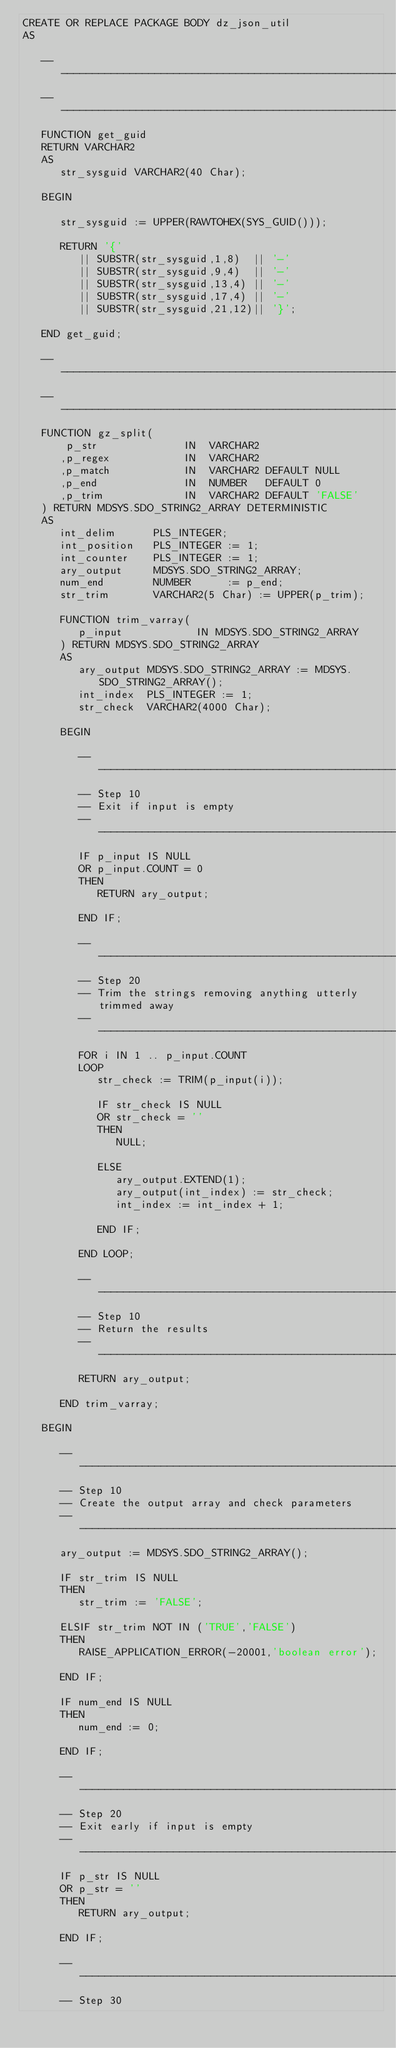<code> <loc_0><loc_0><loc_500><loc_500><_SQL_>CREATE OR REPLACE PACKAGE BODY dz_json_util
AS

   -----------------------------------------------------------------------------
   -----------------------------------------------------------------------------
   FUNCTION get_guid
   RETURN VARCHAR2
   AS
      str_sysguid VARCHAR2(40 Char);
      
   BEGIN
   
      str_sysguid := UPPER(RAWTOHEX(SYS_GUID()));
      
      RETURN '{' 
         || SUBSTR(str_sysguid,1,8)  || '-'
         || SUBSTR(str_sysguid,9,4)  || '-'
         || SUBSTR(str_sysguid,13,4) || '-'
         || SUBSTR(str_sysguid,17,4) || '-'
         || SUBSTR(str_sysguid,21,12)|| '}';
   
   END get_guid;
   
   -----------------------------------------------------------------------------
   -----------------------------------------------------------------------------
   FUNCTION gz_split(
       p_str              IN  VARCHAR2
      ,p_regex            IN  VARCHAR2
      ,p_match            IN  VARCHAR2 DEFAULT NULL
      ,p_end              IN  NUMBER   DEFAULT 0
      ,p_trim             IN  VARCHAR2 DEFAULT 'FALSE'
   ) RETURN MDSYS.SDO_STRING2_ARRAY DETERMINISTIC 
   AS
      int_delim      PLS_INTEGER;
      int_position   PLS_INTEGER := 1;
      int_counter    PLS_INTEGER := 1;
      ary_output     MDSYS.SDO_STRING2_ARRAY;
      num_end        NUMBER      := p_end;
      str_trim       VARCHAR2(5 Char) := UPPER(p_trim);
      
      FUNCTION trim_varray(
         p_input            IN MDSYS.SDO_STRING2_ARRAY
      ) RETURN MDSYS.SDO_STRING2_ARRAY
      AS
         ary_output MDSYS.SDO_STRING2_ARRAY := MDSYS.SDO_STRING2_ARRAY();
         int_index  PLS_INTEGER := 1;
         str_check  VARCHAR2(4000 Char);
         
      BEGIN

         --------------------------------------------------------------------------
         -- Step 10
         -- Exit if input is empty
         --------------------------------------------------------------------------
         IF p_input IS NULL
         OR p_input.COUNT = 0
         THEN
            RETURN ary_output;
            
         END IF;

         --------------------------------------------------------------------------
         -- Step 20
         -- Trim the strings removing anything utterly trimmed away
         --------------------------------------------------------------------------
         FOR i IN 1 .. p_input.COUNT
         LOOP
            str_check := TRIM(p_input(i));
            
            IF str_check IS NULL
            OR str_check = ''
            THEN
               NULL;
               
            ELSE
               ary_output.EXTEND(1);
               ary_output(int_index) := str_check;
               int_index := int_index + 1;
               
            END IF;

         END LOOP;

         --------------------------------------------------------------------------
         -- Step 10
         -- Return the results
         --------------------------------------------------------------------------
         RETURN ary_output;

      END trim_varray;

   BEGIN

      --------------------------------------------------------------------------
      -- Step 10
      -- Create the output array and check parameters
      --------------------------------------------------------------------------
      ary_output := MDSYS.SDO_STRING2_ARRAY();

      IF str_trim IS NULL
      THEN
         str_trim := 'FALSE';
         
      ELSIF str_trim NOT IN ('TRUE','FALSE')
      THEN
         RAISE_APPLICATION_ERROR(-20001,'boolean error');
         
      END IF;

      IF num_end IS NULL
      THEN
         num_end := 0;
         
      END IF;

      --------------------------------------------------------------------------
      -- Step 20
      -- Exit early if input is empty
      --------------------------------------------------------------------------
      IF p_str IS NULL
      OR p_str = ''
      THEN
         RETURN ary_output;
         
      END IF;

      --------------------------------------------------------------------------
      -- Step 30</code> 